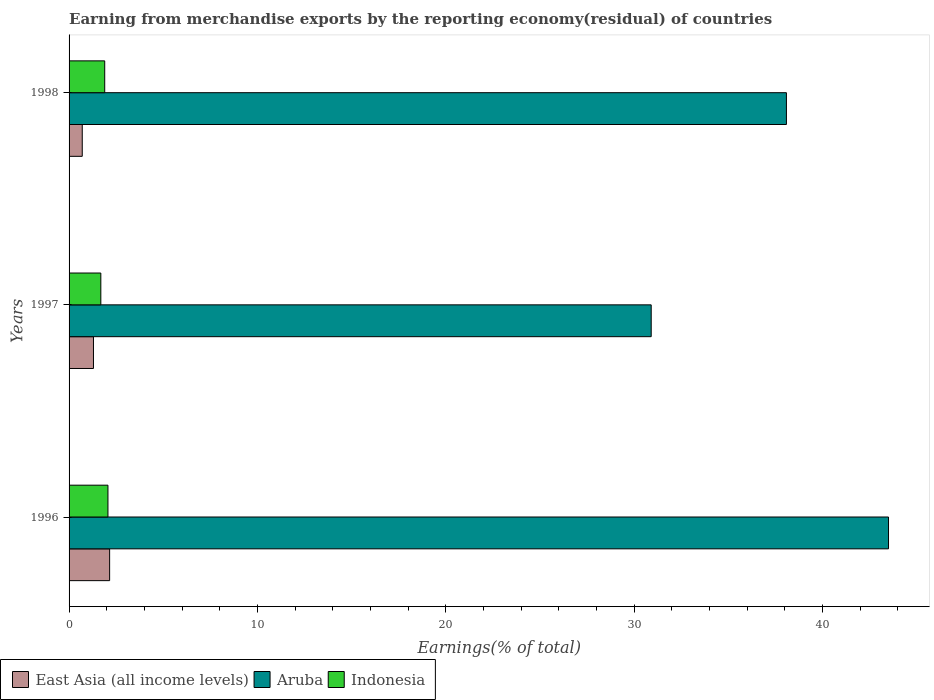How many different coloured bars are there?
Your answer should be very brief. 3. How many groups of bars are there?
Ensure brevity in your answer.  3. Are the number of bars per tick equal to the number of legend labels?
Make the answer very short. Yes. Are the number of bars on each tick of the Y-axis equal?
Offer a terse response. Yes. What is the percentage of amount earned from merchandise exports in East Asia (all income levels) in 1998?
Offer a terse response. 0.7. Across all years, what is the maximum percentage of amount earned from merchandise exports in Indonesia?
Your answer should be very brief. 2.06. Across all years, what is the minimum percentage of amount earned from merchandise exports in East Asia (all income levels)?
Provide a short and direct response. 0.7. In which year was the percentage of amount earned from merchandise exports in Aruba minimum?
Provide a short and direct response. 1997. What is the total percentage of amount earned from merchandise exports in East Asia (all income levels) in the graph?
Offer a terse response. 4.15. What is the difference between the percentage of amount earned from merchandise exports in East Asia (all income levels) in 1996 and that in 1998?
Offer a very short reply. 1.45. What is the difference between the percentage of amount earned from merchandise exports in East Asia (all income levels) in 1996 and the percentage of amount earned from merchandise exports in Indonesia in 1997?
Offer a very short reply. 0.47. What is the average percentage of amount earned from merchandise exports in Aruba per year?
Your response must be concise. 37.49. In the year 1996, what is the difference between the percentage of amount earned from merchandise exports in East Asia (all income levels) and percentage of amount earned from merchandise exports in Indonesia?
Make the answer very short. 0.09. What is the ratio of the percentage of amount earned from merchandise exports in East Asia (all income levels) in 1996 to that in 1997?
Provide a succinct answer. 1.66. Is the difference between the percentage of amount earned from merchandise exports in East Asia (all income levels) in 1996 and 1997 greater than the difference between the percentage of amount earned from merchandise exports in Indonesia in 1996 and 1997?
Offer a terse response. Yes. What is the difference between the highest and the second highest percentage of amount earned from merchandise exports in Aruba?
Keep it short and to the point. 5.42. What is the difference between the highest and the lowest percentage of amount earned from merchandise exports in East Asia (all income levels)?
Give a very brief answer. 1.45. What does the 3rd bar from the top in 1998 represents?
Ensure brevity in your answer.  East Asia (all income levels). What does the 2nd bar from the bottom in 1998 represents?
Keep it short and to the point. Aruba. Is it the case that in every year, the sum of the percentage of amount earned from merchandise exports in East Asia (all income levels) and percentage of amount earned from merchandise exports in Aruba is greater than the percentage of amount earned from merchandise exports in Indonesia?
Ensure brevity in your answer.  Yes. How many bars are there?
Make the answer very short. 9. What is the difference between two consecutive major ticks on the X-axis?
Give a very brief answer. 10. Are the values on the major ticks of X-axis written in scientific E-notation?
Your answer should be very brief. No. Does the graph contain grids?
Make the answer very short. No. What is the title of the graph?
Offer a very short reply. Earning from merchandise exports by the reporting economy(residual) of countries. What is the label or title of the X-axis?
Offer a terse response. Earnings(% of total). What is the label or title of the Y-axis?
Provide a succinct answer. Years. What is the Earnings(% of total) in East Asia (all income levels) in 1996?
Your answer should be compact. 2.15. What is the Earnings(% of total) of Aruba in 1996?
Offer a very short reply. 43.5. What is the Earnings(% of total) in Indonesia in 1996?
Keep it short and to the point. 2.06. What is the Earnings(% of total) in East Asia (all income levels) in 1997?
Keep it short and to the point. 1.29. What is the Earnings(% of total) in Aruba in 1997?
Provide a succinct answer. 30.9. What is the Earnings(% of total) of Indonesia in 1997?
Offer a terse response. 1.69. What is the Earnings(% of total) of East Asia (all income levels) in 1998?
Offer a terse response. 0.7. What is the Earnings(% of total) in Aruba in 1998?
Keep it short and to the point. 38.08. What is the Earnings(% of total) in Indonesia in 1998?
Make the answer very short. 1.89. Across all years, what is the maximum Earnings(% of total) in East Asia (all income levels)?
Your answer should be very brief. 2.15. Across all years, what is the maximum Earnings(% of total) in Aruba?
Offer a terse response. 43.5. Across all years, what is the maximum Earnings(% of total) in Indonesia?
Your response must be concise. 2.06. Across all years, what is the minimum Earnings(% of total) of East Asia (all income levels)?
Your response must be concise. 0.7. Across all years, what is the minimum Earnings(% of total) in Aruba?
Provide a short and direct response. 30.9. Across all years, what is the minimum Earnings(% of total) of Indonesia?
Offer a very short reply. 1.69. What is the total Earnings(% of total) in East Asia (all income levels) in the graph?
Provide a succinct answer. 4.15. What is the total Earnings(% of total) of Aruba in the graph?
Your answer should be compact. 112.48. What is the total Earnings(% of total) in Indonesia in the graph?
Give a very brief answer. 5.64. What is the difference between the Earnings(% of total) of East Asia (all income levels) in 1996 and that in 1997?
Offer a very short reply. 0.86. What is the difference between the Earnings(% of total) of Aruba in 1996 and that in 1997?
Give a very brief answer. 12.6. What is the difference between the Earnings(% of total) of Indonesia in 1996 and that in 1997?
Your answer should be very brief. 0.38. What is the difference between the Earnings(% of total) of East Asia (all income levels) in 1996 and that in 1998?
Ensure brevity in your answer.  1.45. What is the difference between the Earnings(% of total) of Aruba in 1996 and that in 1998?
Your response must be concise. 5.42. What is the difference between the Earnings(% of total) of Indonesia in 1996 and that in 1998?
Offer a terse response. 0.17. What is the difference between the Earnings(% of total) of East Asia (all income levels) in 1997 and that in 1998?
Ensure brevity in your answer.  0.59. What is the difference between the Earnings(% of total) of Aruba in 1997 and that in 1998?
Make the answer very short. -7.18. What is the difference between the Earnings(% of total) of Indonesia in 1997 and that in 1998?
Make the answer very short. -0.21. What is the difference between the Earnings(% of total) in East Asia (all income levels) in 1996 and the Earnings(% of total) in Aruba in 1997?
Ensure brevity in your answer.  -28.75. What is the difference between the Earnings(% of total) of East Asia (all income levels) in 1996 and the Earnings(% of total) of Indonesia in 1997?
Keep it short and to the point. 0.47. What is the difference between the Earnings(% of total) in Aruba in 1996 and the Earnings(% of total) in Indonesia in 1997?
Offer a very short reply. 41.81. What is the difference between the Earnings(% of total) of East Asia (all income levels) in 1996 and the Earnings(% of total) of Aruba in 1998?
Provide a succinct answer. -35.93. What is the difference between the Earnings(% of total) of East Asia (all income levels) in 1996 and the Earnings(% of total) of Indonesia in 1998?
Your response must be concise. 0.26. What is the difference between the Earnings(% of total) in Aruba in 1996 and the Earnings(% of total) in Indonesia in 1998?
Your response must be concise. 41.61. What is the difference between the Earnings(% of total) in East Asia (all income levels) in 1997 and the Earnings(% of total) in Aruba in 1998?
Provide a succinct answer. -36.78. What is the difference between the Earnings(% of total) of East Asia (all income levels) in 1997 and the Earnings(% of total) of Indonesia in 1998?
Provide a succinct answer. -0.6. What is the difference between the Earnings(% of total) of Aruba in 1997 and the Earnings(% of total) of Indonesia in 1998?
Provide a short and direct response. 29.01. What is the average Earnings(% of total) of East Asia (all income levels) per year?
Your answer should be compact. 1.38. What is the average Earnings(% of total) in Aruba per year?
Your answer should be very brief. 37.49. What is the average Earnings(% of total) in Indonesia per year?
Make the answer very short. 1.88. In the year 1996, what is the difference between the Earnings(% of total) in East Asia (all income levels) and Earnings(% of total) in Aruba?
Provide a short and direct response. -41.35. In the year 1996, what is the difference between the Earnings(% of total) of East Asia (all income levels) and Earnings(% of total) of Indonesia?
Give a very brief answer. 0.09. In the year 1996, what is the difference between the Earnings(% of total) in Aruba and Earnings(% of total) in Indonesia?
Offer a very short reply. 41.43. In the year 1997, what is the difference between the Earnings(% of total) of East Asia (all income levels) and Earnings(% of total) of Aruba?
Your answer should be very brief. -29.61. In the year 1997, what is the difference between the Earnings(% of total) in East Asia (all income levels) and Earnings(% of total) in Indonesia?
Offer a terse response. -0.39. In the year 1997, what is the difference between the Earnings(% of total) in Aruba and Earnings(% of total) in Indonesia?
Make the answer very short. 29.22. In the year 1998, what is the difference between the Earnings(% of total) of East Asia (all income levels) and Earnings(% of total) of Aruba?
Provide a succinct answer. -37.38. In the year 1998, what is the difference between the Earnings(% of total) in East Asia (all income levels) and Earnings(% of total) in Indonesia?
Offer a terse response. -1.19. In the year 1998, what is the difference between the Earnings(% of total) of Aruba and Earnings(% of total) of Indonesia?
Your response must be concise. 36.19. What is the ratio of the Earnings(% of total) in East Asia (all income levels) in 1996 to that in 1997?
Ensure brevity in your answer.  1.66. What is the ratio of the Earnings(% of total) in Aruba in 1996 to that in 1997?
Make the answer very short. 1.41. What is the ratio of the Earnings(% of total) of Indonesia in 1996 to that in 1997?
Offer a terse response. 1.22. What is the ratio of the Earnings(% of total) of East Asia (all income levels) in 1996 to that in 1998?
Give a very brief answer. 3.08. What is the ratio of the Earnings(% of total) in Aruba in 1996 to that in 1998?
Keep it short and to the point. 1.14. What is the ratio of the Earnings(% of total) of Indonesia in 1996 to that in 1998?
Make the answer very short. 1.09. What is the ratio of the Earnings(% of total) in East Asia (all income levels) in 1997 to that in 1998?
Keep it short and to the point. 1.85. What is the ratio of the Earnings(% of total) of Aruba in 1997 to that in 1998?
Keep it short and to the point. 0.81. What is the ratio of the Earnings(% of total) in Indonesia in 1997 to that in 1998?
Provide a succinct answer. 0.89. What is the difference between the highest and the second highest Earnings(% of total) of East Asia (all income levels)?
Ensure brevity in your answer.  0.86. What is the difference between the highest and the second highest Earnings(% of total) of Aruba?
Offer a terse response. 5.42. What is the difference between the highest and the second highest Earnings(% of total) of Indonesia?
Ensure brevity in your answer.  0.17. What is the difference between the highest and the lowest Earnings(% of total) in East Asia (all income levels)?
Make the answer very short. 1.45. What is the difference between the highest and the lowest Earnings(% of total) of Aruba?
Provide a succinct answer. 12.6. What is the difference between the highest and the lowest Earnings(% of total) of Indonesia?
Offer a terse response. 0.38. 